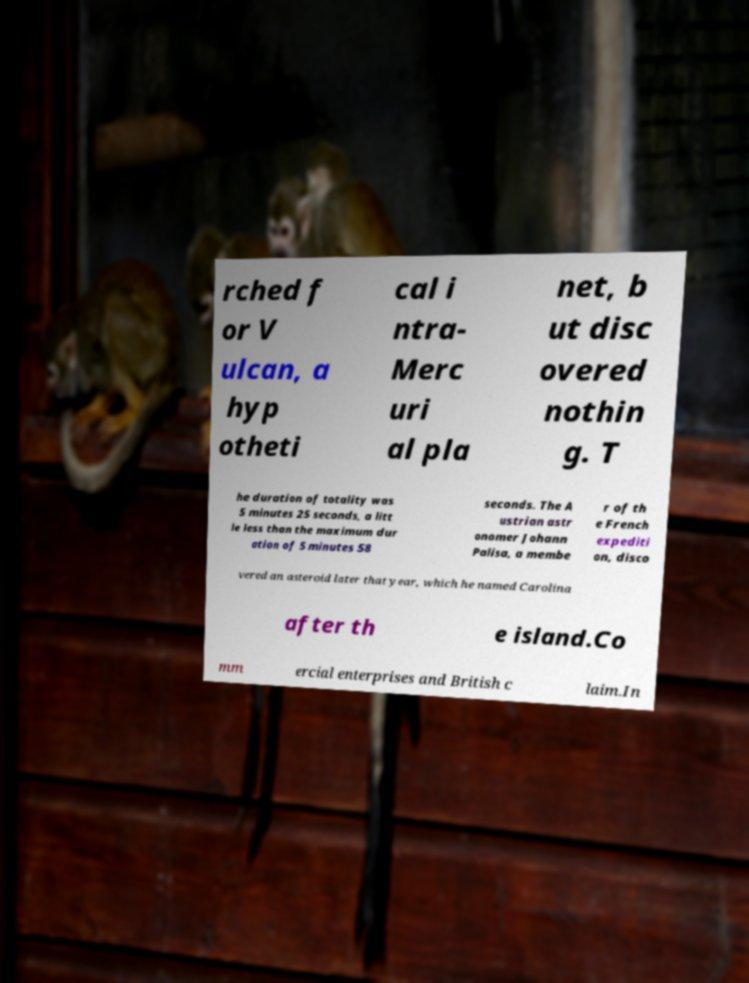Please identify and transcribe the text found in this image. rched f or V ulcan, a hyp otheti cal i ntra- Merc uri al pla net, b ut disc overed nothin g. T he duration of totality was 5 minutes 25 seconds, a litt le less than the maximum dur ation of 5 minutes 58 seconds. The A ustrian astr onomer Johann Palisa, a membe r of th e French expediti on, disco vered an asteroid later that year, which he named Carolina after th e island.Co mm ercial enterprises and British c laim.In 